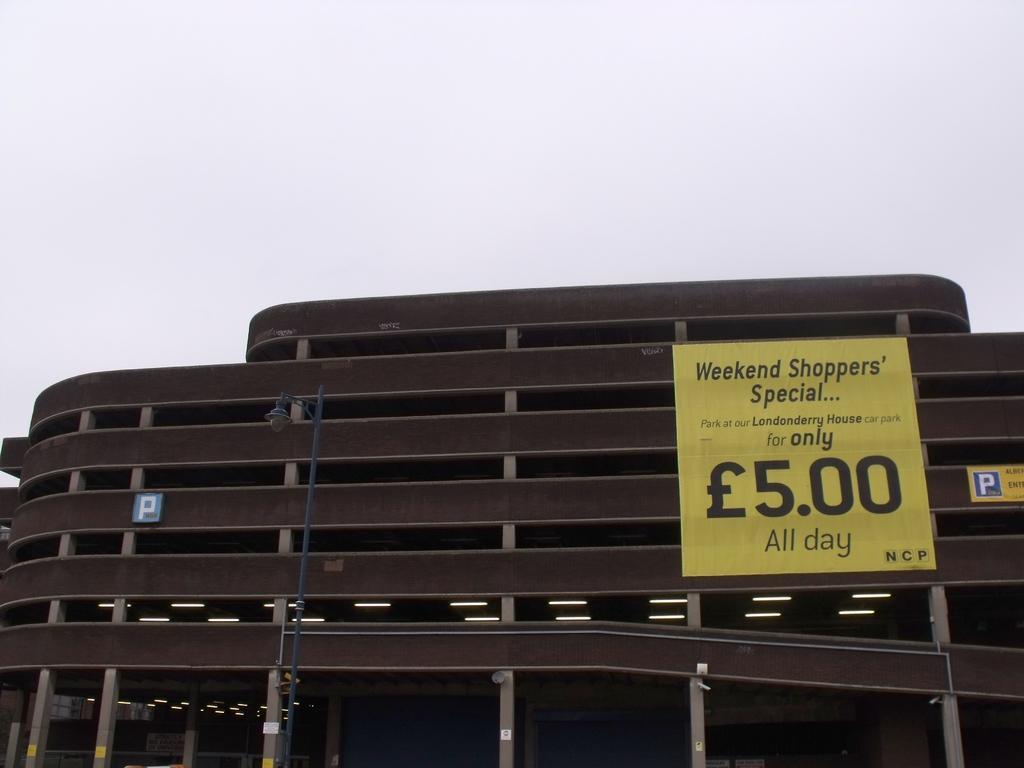Describe this image in one or two sentences. In this picture we can see light on pole, boards on the building, pillars and lights. In the background of the image we can see the sky. 